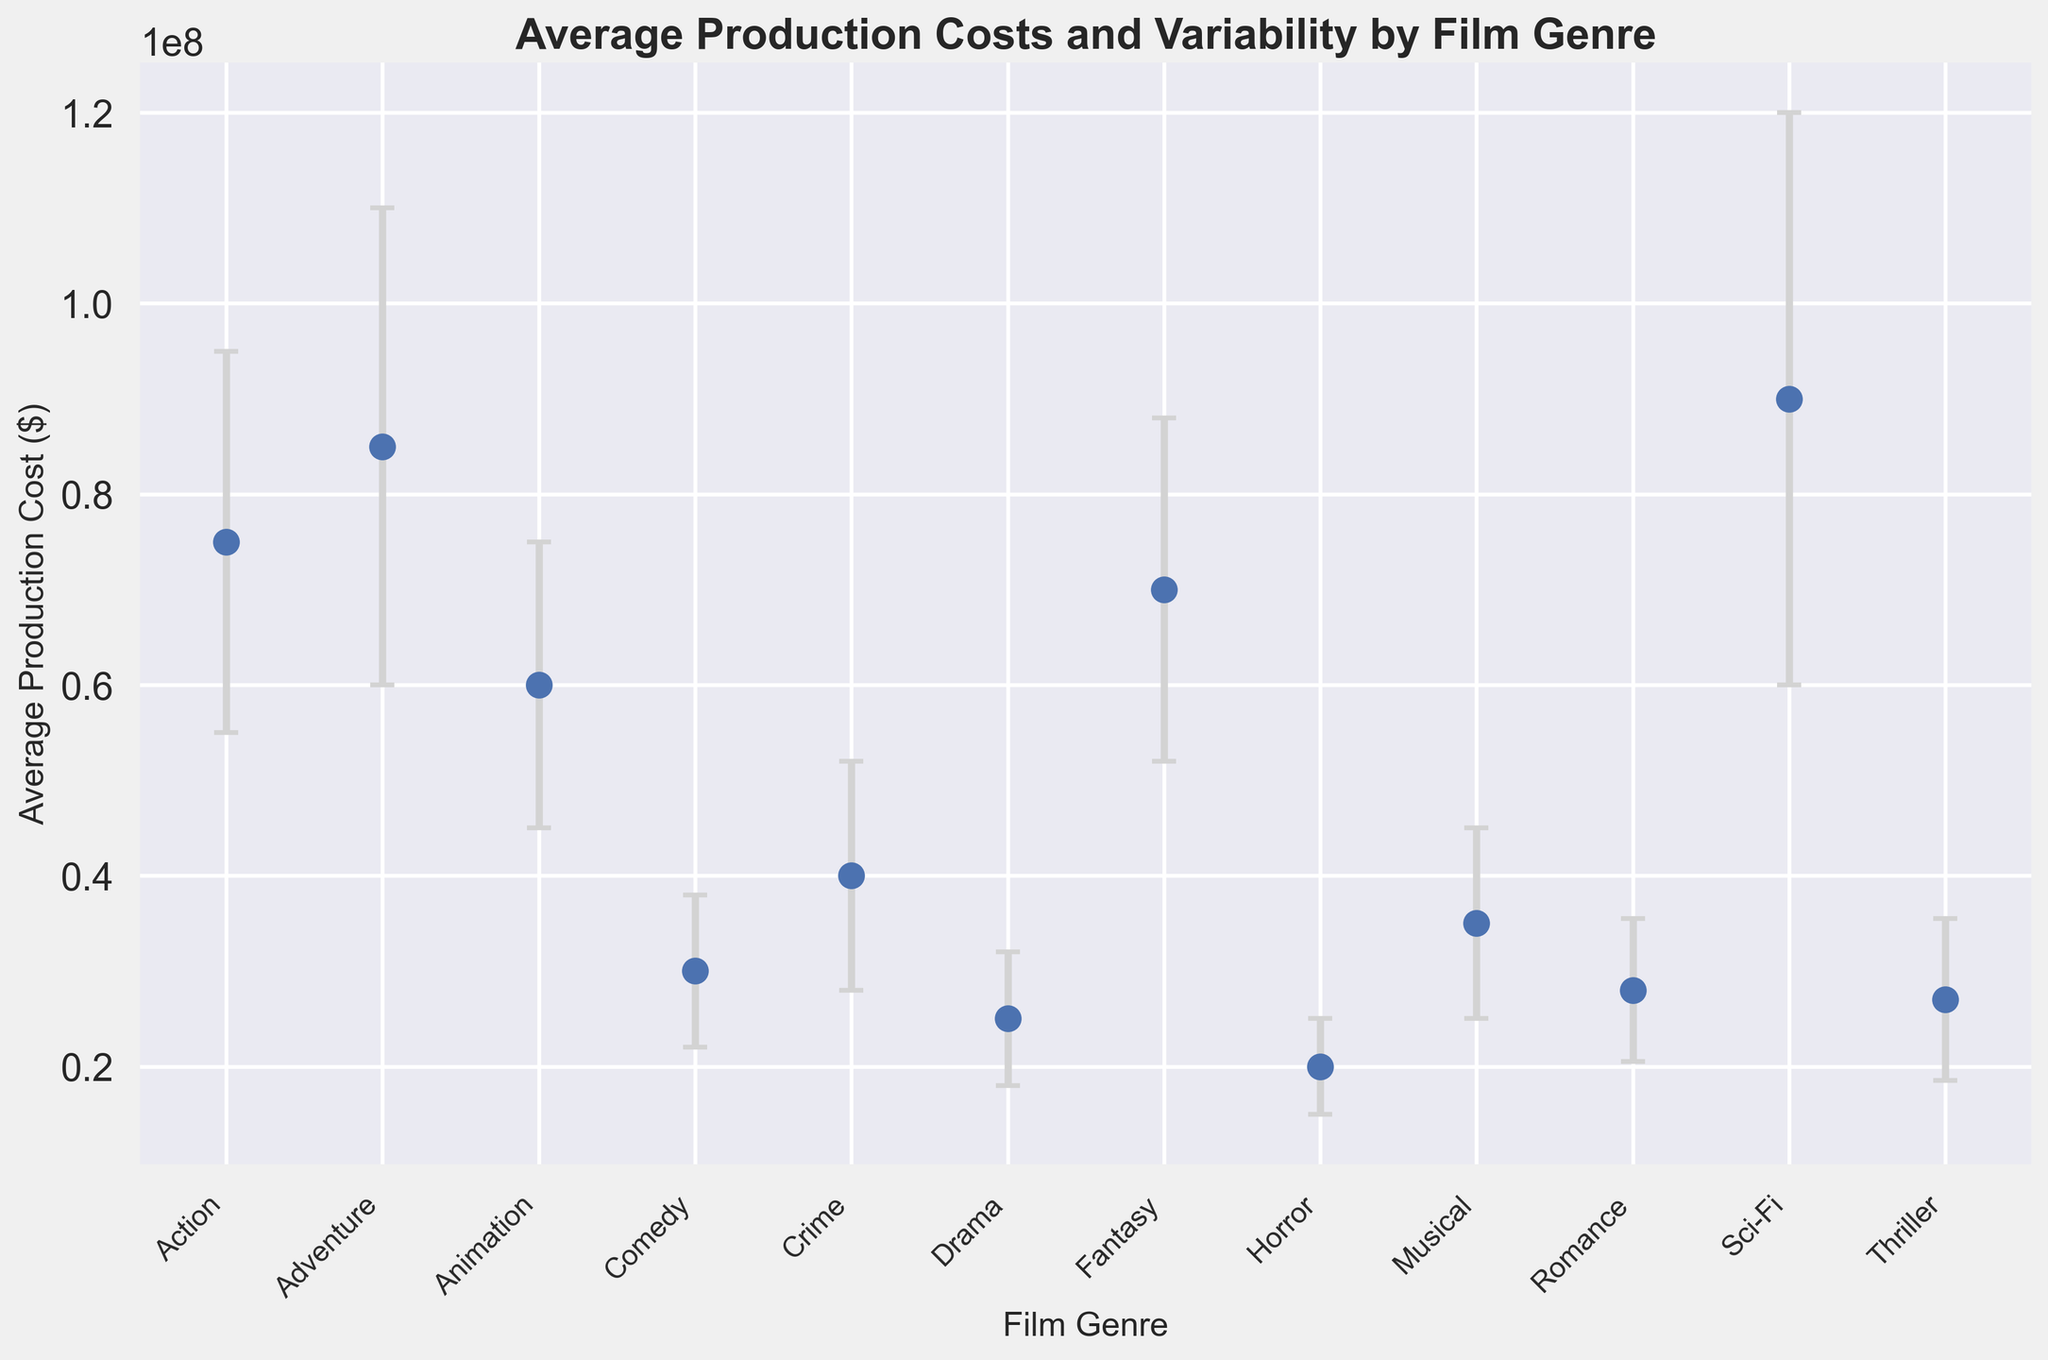Which film genre has the highest average production cost? By looking at the figure, Sci-Fi has the highest point on the cost scale compared to other genres.
Answer: Sci-Fi Which film genre has the lowest average production cost? By looking at the figure, Horror is at the lowest point on the cost scale compared to other genres.
Answer: Horror How much higher is the average production cost of Adventure films compared to Comedy films? The average production cost of Adventure films is $85,000,000 and that of Comedy films is $30,000,000. The difference is $85,000,000 - $30,000,000 = $55,000,000.
Answer: $55,000,000 Which genre has the largest error bar, indicating the most variability in production costs? By looking at the lengths of the error bars, Sci-Fi has the longest error bar, indicating the most variability.
Answer: Sci-Fi Which film genre has the lowest standard deviation in production costs? By looking at the lengths of the error bars, Horror has the shortest error bar, indicating the lowest standard deviation.
Answer: Horror How do the average production costs of Drama and Crime films compare? The average production cost of Drama films is $25,000,000, and for Crime films, it is $40,000,000. Hence, Crime films have a higher average production cost than Drama films.
Answer: Crime films What is the range of average production costs for the genres with error bars? The highest average production cost is for Sci-Fi at $90,000,000, and the lowest is for Horror at $20,000,000. Therefore, the range is $90,000,000 - $20,000,000 = $70,000,000.
Answer: $70,000,000 Which film genre's average production cost is exactly between Comedy and Romance? The production cost of Comedy is $30,000,000 and Romance is $28,000,000. The average of these two is $(30,000,000 + 28,000,000)/2 = $29,000,000. The closest genre is Thriller at $27,000,000.
Answer: Thriller What is the combined average production cost of Animation and Fantasy films? The average production cost of Animation films is $60,000,000 and that of Fantasy films is $70,000,000. The combined cost is $60,000,000 + $70,000,000 = $130,000,000.
Answer: $130,000,000 What's the difference in the average production cost between the highest and lowest-variability genres? The highest-variability genre is Sci-Fi with an average production cost of $90,000,000, and the lowest-variability genre is Horror with an average production cost of $20,000,000. The difference is $90,000,000 - $20,000,000 = $70,000,000.
Answer: $70,000,000 